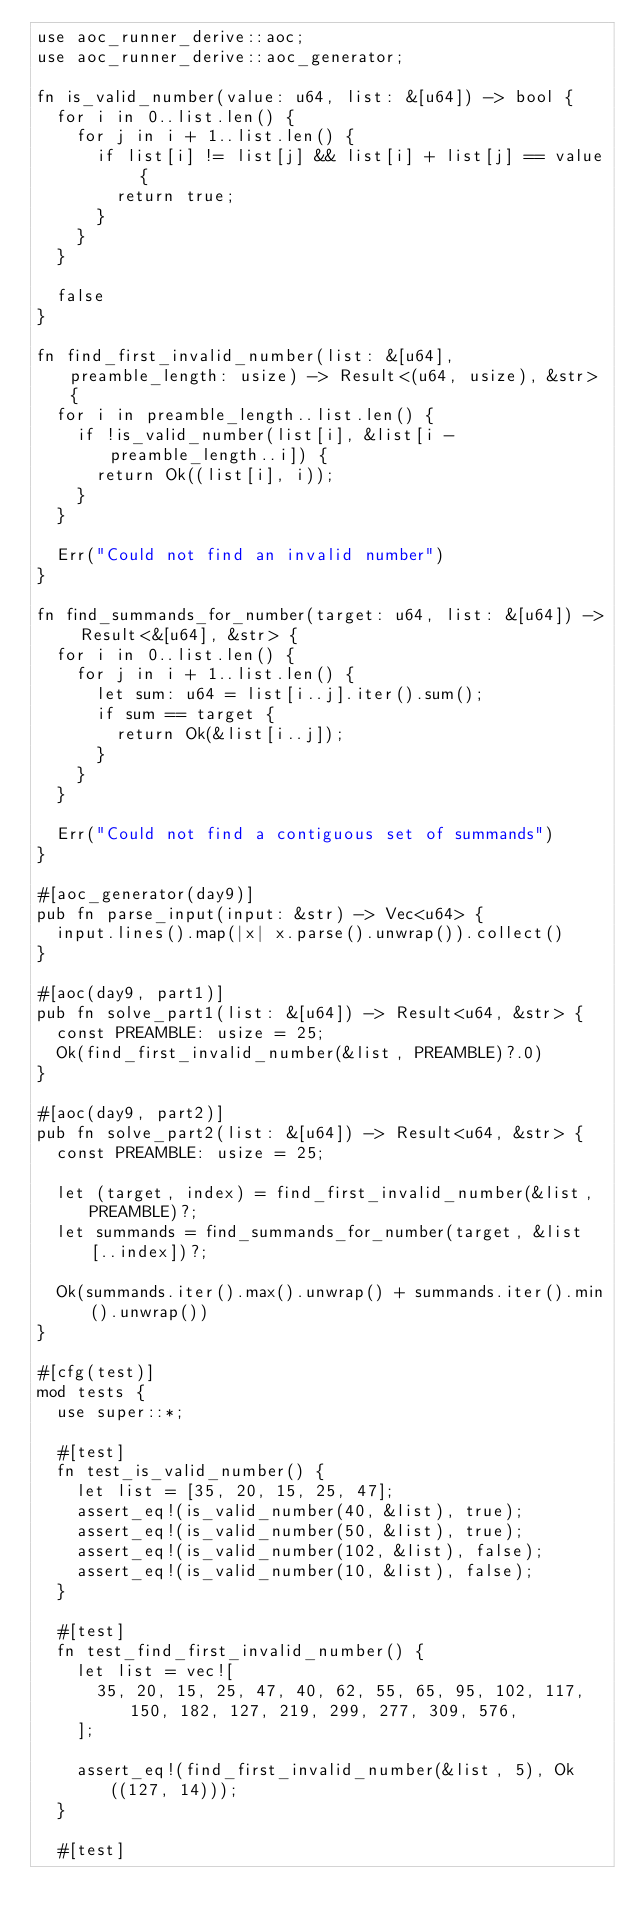Convert code to text. <code><loc_0><loc_0><loc_500><loc_500><_Rust_>use aoc_runner_derive::aoc;
use aoc_runner_derive::aoc_generator;

fn is_valid_number(value: u64, list: &[u64]) -> bool {
  for i in 0..list.len() {
    for j in i + 1..list.len() {
      if list[i] != list[j] && list[i] + list[j] == value {
        return true;
      }
    }
  }

  false
}

fn find_first_invalid_number(list: &[u64], preamble_length: usize) -> Result<(u64, usize), &str> {
  for i in preamble_length..list.len() {
    if !is_valid_number(list[i], &list[i - preamble_length..i]) {
      return Ok((list[i], i));
    }
  }

  Err("Could not find an invalid number")
}

fn find_summands_for_number(target: u64, list: &[u64]) -> Result<&[u64], &str> {
  for i in 0..list.len() {
    for j in i + 1..list.len() {
      let sum: u64 = list[i..j].iter().sum();
      if sum == target {
        return Ok(&list[i..j]);
      }
    }
  }

  Err("Could not find a contiguous set of summands")
}

#[aoc_generator(day9)]
pub fn parse_input(input: &str) -> Vec<u64> {
  input.lines().map(|x| x.parse().unwrap()).collect()
}

#[aoc(day9, part1)]
pub fn solve_part1(list: &[u64]) -> Result<u64, &str> {
  const PREAMBLE: usize = 25;
  Ok(find_first_invalid_number(&list, PREAMBLE)?.0)
}

#[aoc(day9, part2)]
pub fn solve_part2(list: &[u64]) -> Result<u64, &str> {
  const PREAMBLE: usize = 25;

  let (target, index) = find_first_invalid_number(&list, PREAMBLE)?;
  let summands = find_summands_for_number(target, &list[..index])?;

  Ok(summands.iter().max().unwrap() + summands.iter().min().unwrap())
}

#[cfg(test)]
mod tests {
  use super::*;

  #[test]
  fn test_is_valid_number() {
    let list = [35, 20, 15, 25, 47];
    assert_eq!(is_valid_number(40, &list), true);
    assert_eq!(is_valid_number(50, &list), true);
    assert_eq!(is_valid_number(102, &list), false);
    assert_eq!(is_valid_number(10, &list), false);
  }

  #[test]
  fn test_find_first_invalid_number() {
    let list = vec![
      35, 20, 15, 25, 47, 40, 62, 55, 65, 95, 102, 117, 150, 182, 127, 219, 299, 277, 309, 576,
    ];

    assert_eq!(find_first_invalid_number(&list, 5), Ok((127, 14)));
  }

  #[test]</code> 